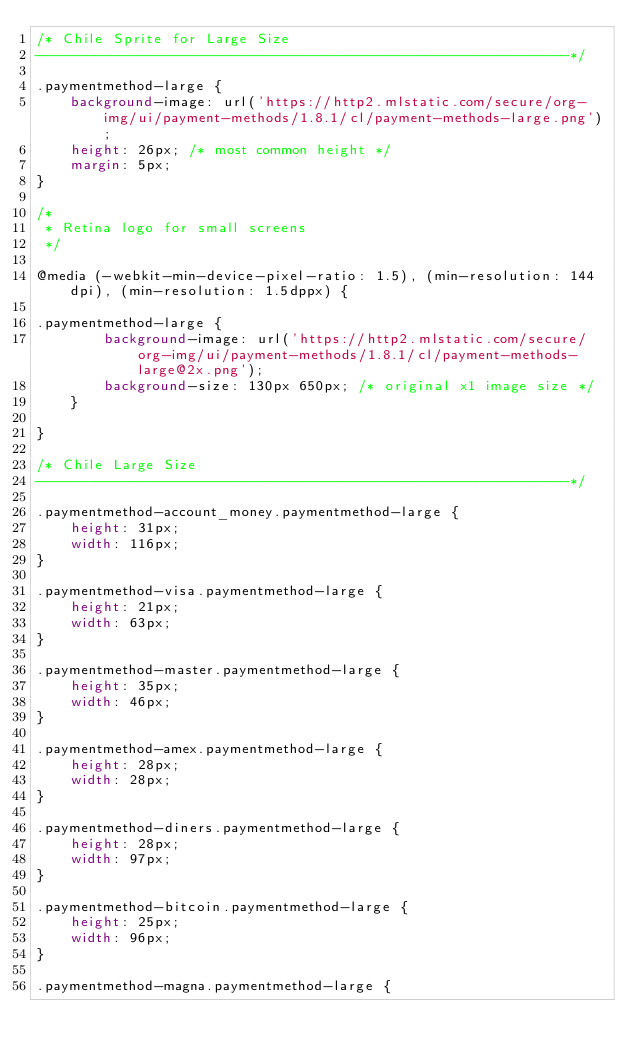<code> <loc_0><loc_0><loc_500><loc_500><_CSS_>/* Chile Sprite for Large Size
---------------------------------------------------------------*/

.paymentmethod-large {
    background-image: url('https://http2.mlstatic.com/secure/org-img/ui/payment-methods/1.8.1/cl/payment-methods-large.png');
    height: 26px; /* most common height */
    margin: 5px;
}

/*
 * Retina logo for small screens
 */

@media (-webkit-min-device-pixel-ratio: 1.5), (min-resolution: 144dpi), (min-resolution: 1.5dppx) {

.paymentmethod-large {
        background-image: url('https://http2.mlstatic.com/secure/org-img/ui/payment-methods/1.8.1/cl/payment-methods-large@2x.png');
        background-size: 130px 650px; /* original x1 image size */
    }

}

/* Chile Large Size
---------------------------------------------------------------*/

.paymentmethod-account_money.paymentmethod-large {
    height: 31px;
    width: 116px;
}

.paymentmethod-visa.paymentmethod-large {
    height: 21px;
    width: 63px;
}

.paymentmethod-master.paymentmethod-large {
    height: 35px;
    width: 46px;
}

.paymentmethod-amex.paymentmethod-large {
    height: 28px;
    width: 28px;
}

.paymentmethod-diners.paymentmethod-large {
    height: 28px;
    width: 97px;
}

.paymentmethod-bitcoin.paymentmethod-large {
    height: 25px;
    width: 96px;
}

.paymentmethod-magna.paymentmethod-large {</code> 